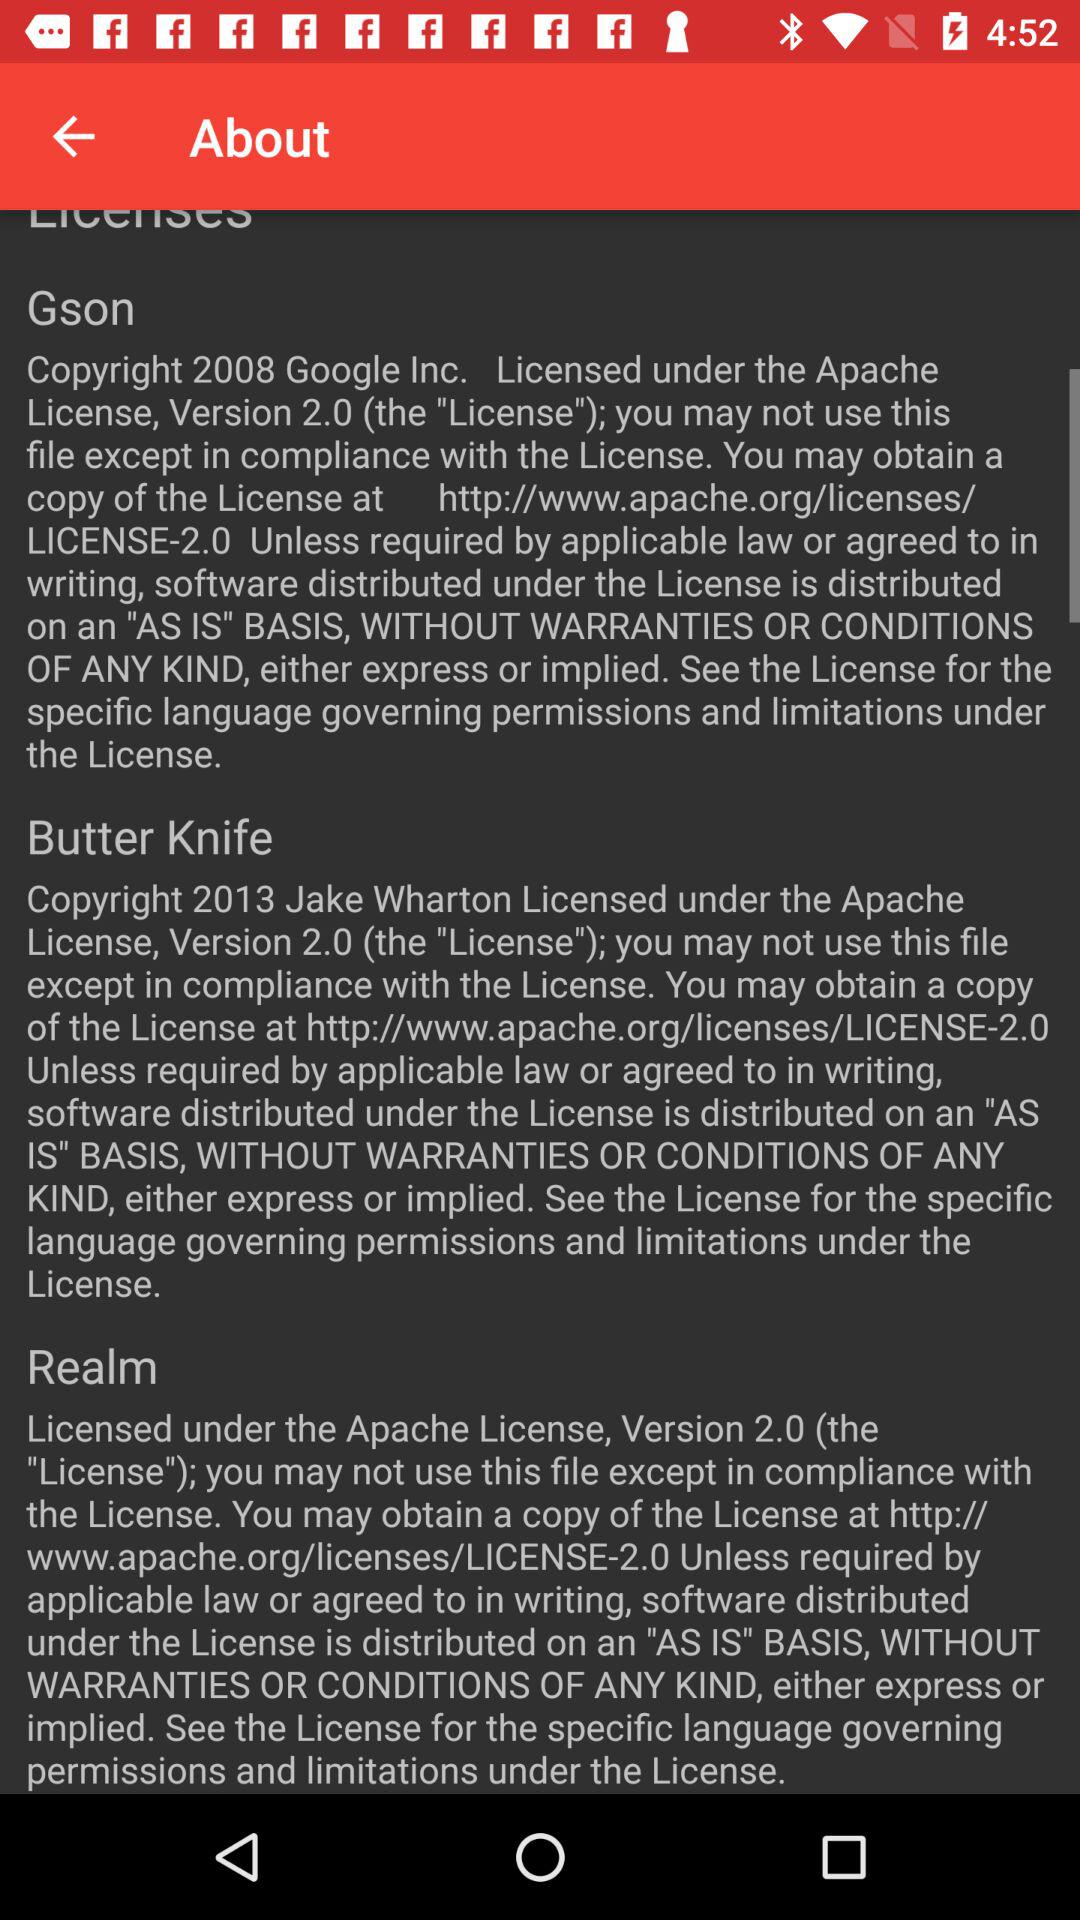In which year butter knife developed?
When the provided information is insufficient, respond with <no answer>. <no answer> 